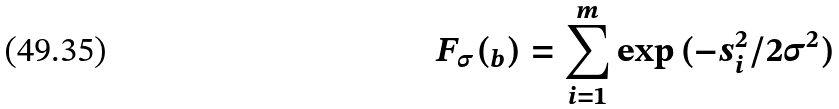Convert formula to latex. <formula><loc_0><loc_0><loc_500><loc_500>F _ { \sigma } ( _ { b } ) = \sum _ { i = 1 } ^ { m } \exp { ( - s _ { i } ^ { 2 } / 2 \sigma ^ { 2 } ) }</formula> 